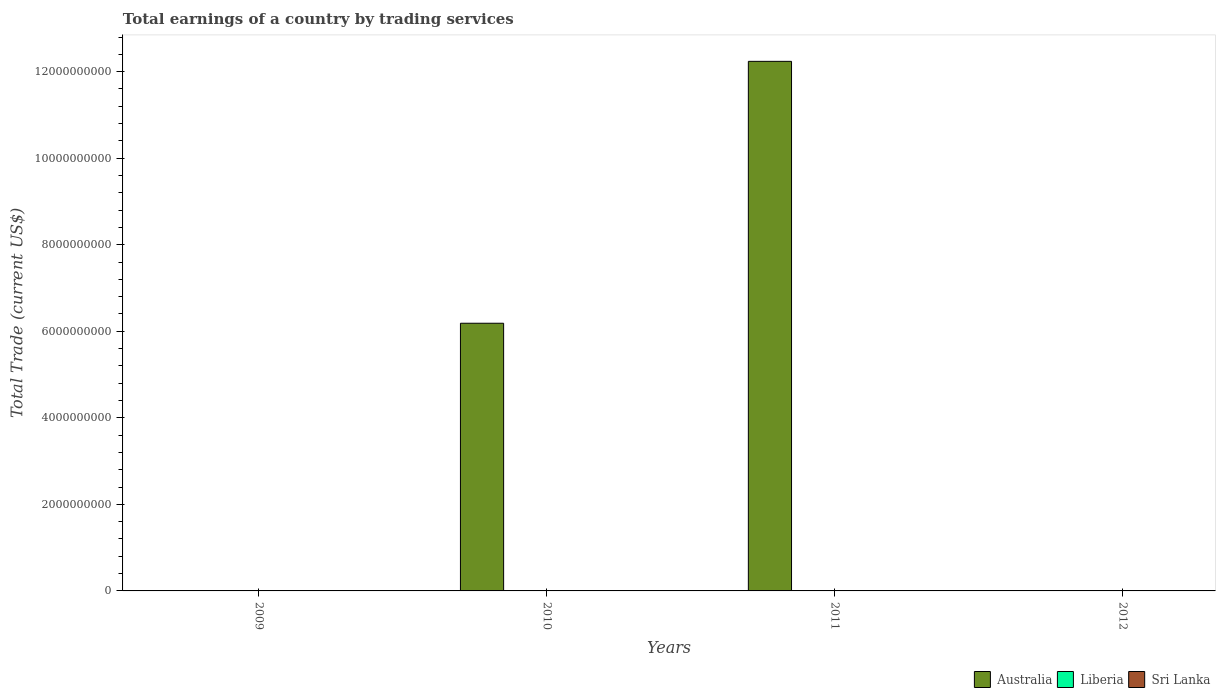How many different coloured bars are there?
Your answer should be very brief. 1. Are the number of bars on each tick of the X-axis equal?
Keep it short and to the point. No. What is the label of the 2nd group of bars from the left?
Give a very brief answer. 2010. In how many cases, is the number of bars for a given year not equal to the number of legend labels?
Offer a terse response. 4. Across all years, what is the maximum total earnings in Australia?
Keep it short and to the point. 1.22e+1. What is the difference between the total earnings in Australia in 2010 and that in 2011?
Your answer should be compact. -6.05e+09. In how many years, is the total earnings in Australia greater than 6400000000 US$?
Provide a succinct answer. 1. What is the ratio of the total earnings in Australia in 2010 to that in 2011?
Give a very brief answer. 0.51. What is the difference between the highest and the lowest total earnings in Australia?
Your answer should be very brief. 1.22e+1. Is the sum of the total earnings in Australia in 2010 and 2011 greater than the maximum total earnings in Liberia across all years?
Provide a short and direct response. Yes. Is it the case that in every year, the sum of the total earnings in Australia and total earnings in Liberia is greater than the total earnings in Sri Lanka?
Ensure brevity in your answer.  No. What is the difference between two consecutive major ticks on the Y-axis?
Offer a terse response. 2.00e+09. Are the values on the major ticks of Y-axis written in scientific E-notation?
Your answer should be very brief. No. Where does the legend appear in the graph?
Provide a succinct answer. Bottom right. How many legend labels are there?
Ensure brevity in your answer.  3. How are the legend labels stacked?
Give a very brief answer. Horizontal. What is the title of the graph?
Provide a short and direct response. Total earnings of a country by trading services. Does "Ukraine" appear as one of the legend labels in the graph?
Your answer should be very brief. No. What is the label or title of the Y-axis?
Ensure brevity in your answer.  Total Trade (current US$). What is the Total Trade (current US$) of Liberia in 2009?
Offer a very short reply. 0. What is the Total Trade (current US$) in Sri Lanka in 2009?
Provide a short and direct response. 0. What is the Total Trade (current US$) of Australia in 2010?
Your answer should be very brief. 6.19e+09. What is the Total Trade (current US$) in Sri Lanka in 2010?
Offer a terse response. 0. What is the Total Trade (current US$) of Australia in 2011?
Make the answer very short. 1.22e+1. What is the Total Trade (current US$) of Sri Lanka in 2012?
Make the answer very short. 0. Across all years, what is the maximum Total Trade (current US$) of Australia?
Ensure brevity in your answer.  1.22e+1. What is the total Total Trade (current US$) of Australia in the graph?
Provide a short and direct response. 1.84e+1. What is the total Total Trade (current US$) in Liberia in the graph?
Keep it short and to the point. 0. What is the total Total Trade (current US$) of Sri Lanka in the graph?
Provide a short and direct response. 0. What is the difference between the Total Trade (current US$) in Australia in 2010 and that in 2011?
Your response must be concise. -6.05e+09. What is the average Total Trade (current US$) of Australia per year?
Offer a very short reply. 4.61e+09. What is the ratio of the Total Trade (current US$) in Australia in 2010 to that in 2011?
Offer a very short reply. 0.51. What is the difference between the highest and the lowest Total Trade (current US$) of Australia?
Your answer should be very brief. 1.22e+1. 